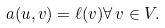<formula> <loc_0><loc_0><loc_500><loc_500>a ( u , v ) = \ell ( v ) \forall \, v \in V .</formula> 